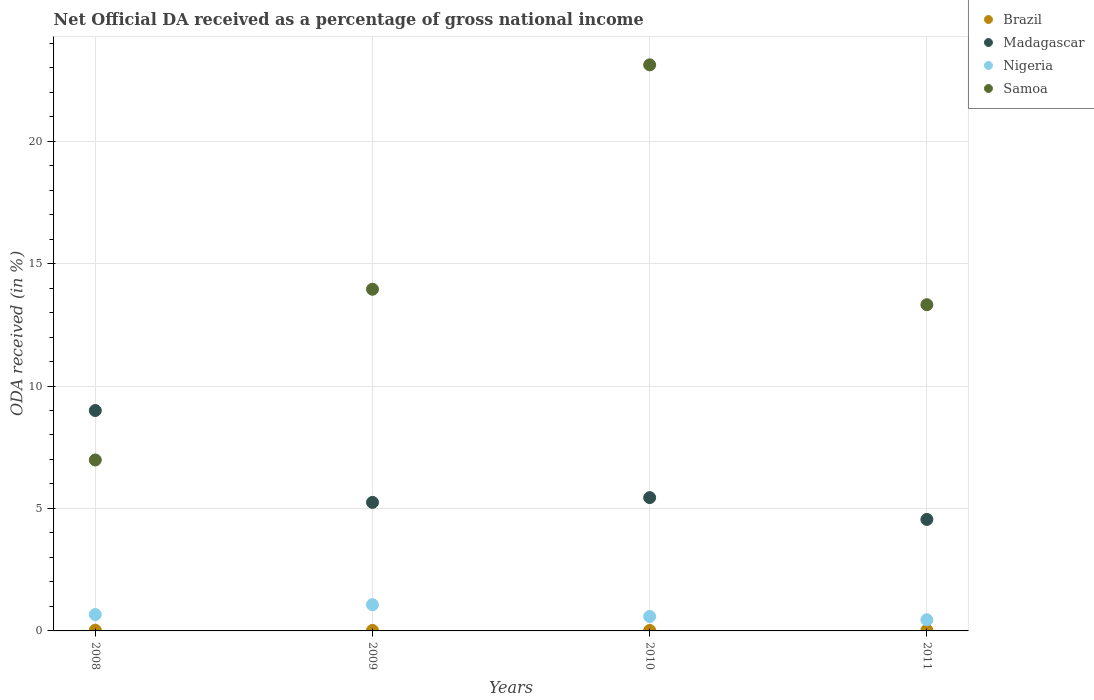How many different coloured dotlines are there?
Ensure brevity in your answer.  4. What is the net official DA received in Brazil in 2011?
Offer a very short reply. 0.03. Across all years, what is the maximum net official DA received in Samoa?
Your answer should be very brief. 23.11. Across all years, what is the minimum net official DA received in Brazil?
Provide a short and direct response. 0.02. In which year was the net official DA received in Nigeria minimum?
Ensure brevity in your answer.  2011. What is the total net official DA received in Nigeria in the graph?
Provide a succinct answer. 2.78. What is the difference between the net official DA received in Madagascar in 2009 and that in 2010?
Keep it short and to the point. -0.19. What is the difference between the net official DA received in Nigeria in 2010 and the net official DA received in Brazil in 2008?
Provide a short and direct response. 0.56. What is the average net official DA received in Nigeria per year?
Offer a very short reply. 0.7. In the year 2011, what is the difference between the net official DA received in Samoa and net official DA received in Nigeria?
Provide a short and direct response. 12.86. In how many years, is the net official DA received in Brazil greater than 8 %?
Offer a terse response. 0. What is the ratio of the net official DA received in Brazil in 2010 to that in 2011?
Provide a succinct answer. 0.66. Is the difference between the net official DA received in Samoa in 2008 and 2010 greater than the difference between the net official DA received in Nigeria in 2008 and 2010?
Keep it short and to the point. No. What is the difference between the highest and the second highest net official DA received in Madagascar?
Provide a short and direct response. 3.56. What is the difference between the highest and the lowest net official DA received in Samoa?
Provide a short and direct response. 16.13. Is it the case that in every year, the sum of the net official DA received in Nigeria and net official DA received in Madagascar  is greater than the sum of net official DA received in Brazil and net official DA received in Samoa?
Offer a terse response. Yes. Is the net official DA received in Samoa strictly greater than the net official DA received in Brazil over the years?
Provide a short and direct response. Yes. Is the net official DA received in Madagascar strictly less than the net official DA received in Brazil over the years?
Offer a terse response. No. How many dotlines are there?
Your response must be concise. 4. What is the difference between two consecutive major ticks on the Y-axis?
Keep it short and to the point. 5. Are the values on the major ticks of Y-axis written in scientific E-notation?
Make the answer very short. No. Where does the legend appear in the graph?
Give a very brief answer. Top right. How many legend labels are there?
Ensure brevity in your answer.  4. How are the legend labels stacked?
Give a very brief answer. Vertical. What is the title of the graph?
Provide a succinct answer. Net Official DA received as a percentage of gross national income. Does "Uruguay" appear as one of the legend labels in the graph?
Offer a terse response. No. What is the label or title of the Y-axis?
Offer a terse response. ODA received (in %). What is the ODA received (in %) in Brazil in 2008?
Give a very brief answer. 0.03. What is the ODA received (in %) in Madagascar in 2008?
Offer a very short reply. 9. What is the ODA received (in %) in Nigeria in 2008?
Keep it short and to the point. 0.67. What is the ODA received (in %) in Samoa in 2008?
Your response must be concise. 6.98. What is the ODA received (in %) in Brazil in 2009?
Keep it short and to the point. 0.02. What is the ODA received (in %) in Madagascar in 2009?
Provide a short and direct response. 5.25. What is the ODA received (in %) in Nigeria in 2009?
Provide a succinct answer. 1.07. What is the ODA received (in %) in Samoa in 2009?
Make the answer very short. 13.95. What is the ODA received (in %) in Brazil in 2010?
Your answer should be very brief. 0.02. What is the ODA received (in %) of Madagascar in 2010?
Provide a short and direct response. 5.44. What is the ODA received (in %) in Nigeria in 2010?
Keep it short and to the point. 0.59. What is the ODA received (in %) of Samoa in 2010?
Ensure brevity in your answer.  23.11. What is the ODA received (in %) in Brazil in 2011?
Your response must be concise. 0.03. What is the ODA received (in %) of Madagascar in 2011?
Offer a terse response. 4.55. What is the ODA received (in %) of Nigeria in 2011?
Give a very brief answer. 0.45. What is the ODA received (in %) in Samoa in 2011?
Provide a short and direct response. 13.32. Across all years, what is the maximum ODA received (in %) in Brazil?
Give a very brief answer. 0.03. Across all years, what is the maximum ODA received (in %) in Madagascar?
Give a very brief answer. 9. Across all years, what is the maximum ODA received (in %) in Nigeria?
Provide a short and direct response. 1.07. Across all years, what is the maximum ODA received (in %) in Samoa?
Offer a very short reply. 23.11. Across all years, what is the minimum ODA received (in %) in Brazil?
Offer a terse response. 0.02. Across all years, what is the minimum ODA received (in %) in Madagascar?
Your answer should be very brief. 4.55. Across all years, what is the minimum ODA received (in %) in Nigeria?
Keep it short and to the point. 0.45. Across all years, what is the minimum ODA received (in %) in Samoa?
Keep it short and to the point. 6.98. What is the total ODA received (in %) of Brazil in the graph?
Provide a short and direct response. 0.1. What is the total ODA received (in %) in Madagascar in the graph?
Provide a succinct answer. 24.24. What is the total ODA received (in %) of Nigeria in the graph?
Your answer should be compact. 2.78. What is the total ODA received (in %) in Samoa in the graph?
Make the answer very short. 57.36. What is the difference between the ODA received (in %) in Brazil in 2008 and that in 2009?
Offer a very short reply. 0.01. What is the difference between the ODA received (in %) in Madagascar in 2008 and that in 2009?
Keep it short and to the point. 3.75. What is the difference between the ODA received (in %) in Nigeria in 2008 and that in 2009?
Your answer should be very brief. -0.4. What is the difference between the ODA received (in %) in Samoa in 2008 and that in 2009?
Give a very brief answer. -6.97. What is the difference between the ODA received (in %) in Brazil in 2008 and that in 2010?
Give a very brief answer. 0.01. What is the difference between the ODA received (in %) in Madagascar in 2008 and that in 2010?
Make the answer very short. 3.56. What is the difference between the ODA received (in %) in Nigeria in 2008 and that in 2010?
Provide a succinct answer. 0.08. What is the difference between the ODA received (in %) of Samoa in 2008 and that in 2010?
Offer a very short reply. -16.13. What is the difference between the ODA received (in %) in Brazil in 2008 and that in 2011?
Your answer should be very brief. -0. What is the difference between the ODA received (in %) of Madagascar in 2008 and that in 2011?
Your answer should be very brief. 4.45. What is the difference between the ODA received (in %) in Nigeria in 2008 and that in 2011?
Keep it short and to the point. 0.21. What is the difference between the ODA received (in %) of Samoa in 2008 and that in 2011?
Give a very brief answer. -6.34. What is the difference between the ODA received (in %) of Madagascar in 2009 and that in 2010?
Ensure brevity in your answer.  -0.19. What is the difference between the ODA received (in %) of Nigeria in 2009 and that in 2010?
Your answer should be compact. 0.48. What is the difference between the ODA received (in %) of Samoa in 2009 and that in 2010?
Provide a succinct answer. -9.16. What is the difference between the ODA received (in %) in Brazil in 2009 and that in 2011?
Ensure brevity in your answer.  -0.01. What is the difference between the ODA received (in %) in Madagascar in 2009 and that in 2011?
Make the answer very short. 0.7. What is the difference between the ODA received (in %) in Nigeria in 2009 and that in 2011?
Your response must be concise. 0.61. What is the difference between the ODA received (in %) of Samoa in 2009 and that in 2011?
Ensure brevity in your answer.  0.63. What is the difference between the ODA received (in %) in Brazil in 2010 and that in 2011?
Your answer should be compact. -0.01. What is the difference between the ODA received (in %) of Madagascar in 2010 and that in 2011?
Make the answer very short. 0.89. What is the difference between the ODA received (in %) in Nigeria in 2010 and that in 2011?
Ensure brevity in your answer.  0.14. What is the difference between the ODA received (in %) in Samoa in 2010 and that in 2011?
Provide a succinct answer. 9.79. What is the difference between the ODA received (in %) of Brazil in 2008 and the ODA received (in %) of Madagascar in 2009?
Offer a very short reply. -5.22. What is the difference between the ODA received (in %) in Brazil in 2008 and the ODA received (in %) in Nigeria in 2009?
Offer a very short reply. -1.04. What is the difference between the ODA received (in %) of Brazil in 2008 and the ODA received (in %) of Samoa in 2009?
Ensure brevity in your answer.  -13.92. What is the difference between the ODA received (in %) of Madagascar in 2008 and the ODA received (in %) of Nigeria in 2009?
Ensure brevity in your answer.  7.93. What is the difference between the ODA received (in %) of Madagascar in 2008 and the ODA received (in %) of Samoa in 2009?
Your answer should be very brief. -4.95. What is the difference between the ODA received (in %) in Nigeria in 2008 and the ODA received (in %) in Samoa in 2009?
Ensure brevity in your answer.  -13.28. What is the difference between the ODA received (in %) of Brazil in 2008 and the ODA received (in %) of Madagascar in 2010?
Offer a very short reply. -5.41. What is the difference between the ODA received (in %) in Brazil in 2008 and the ODA received (in %) in Nigeria in 2010?
Your answer should be compact. -0.56. What is the difference between the ODA received (in %) of Brazil in 2008 and the ODA received (in %) of Samoa in 2010?
Provide a succinct answer. -23.08. What is the difference between the ODA received (in %) of Madagascar in 2008 and the ODA received (in %) of Nigeria in 2010?
Make the answer very short. 8.41. What is the difference between the ODA received (in %) in Madagascar in 2008 and the ODA received (in %) in Samoa in 2010?
Your answer should be very brief. -14.11. What is the difference between the ODA received (in %) of Nigeria in 2008 and the ODA received (in %) of Samoa in 2010?
Your answer should be compact. -22.44. What is the difference between the ODA received (in %) of Brazil in 2008 and the ODA received (in %) of Madagascar in 2011?
Your response must be concise. -4.52. What is the difference between the ODA received (in %) in Brazil in 2008 and the ODA received (in %) in Nigeria in 2011?
Your answer should be compact. -0.43. What is the difference between the ODA received (in %) of Brazil in 2008 and the ODA received (in %) of Samoa in 2011?
Your answer should be very brief. -13.29. What is the difference between the ODA received (in %) in Madagascar in 2008 and the ODA received (in %) in Nigeria in 2011?
Offer a very short reply. 8.54. What is the difference between the ODA received (in %) of Madagascar in 2008 and the ODA received (in %) of Samoa in 2011?
Ensure brevity in your answer.  -4.32. What is the difference between the ODA received (in %) of Nigeria in 2008 and the ODA received (in %) of Samoa in 2011?
Give a very brief answer. -12.65. What is the difference between the ODA received (in %) of Brazil in 2009 and the ODA received (in %) of Madagascar in 2010?
Ensure brevity in your answer.  -5.42. What is the difference between the ODA received (in %) of Brazil in 2009 and the ODA received (in %) of Nigeria in 2010?
Make the answer very short. -0.57. What is the difference between the ODA received (in %) in Brazil in 2009 and the ODA received (in %) in Samoa in 2010?
Make the answer very short. -23.09. What is the difference between the ODA received (in %) in Madagascar in 2009 and the ODA received (in %) in Nigeria in 2010?
Give a very brief answer. 4.66. What is the difference between the ODA received (in %) of Madagascar in 2009 and the ODA received (in %) of Samoa in 2010?
Keep it short and to the point. -17.86. What is the difference between the ODA received (in %) of Nigeria in 2009 and the ODA received (in %) of Samoa in 2010?
Your answer should be very brief. -22.04. What is the difference between the ODA received (in %) in Brazil in 2009 and the ODA received (in %) in Madagascar in 2011?
Your response must be concise. -4.53. What is the difference between the ODA received (in %) of Brazil in 2009 and the ODA received (in %) of Nigeria in 2011?
Offer a very short reply. -0.43. What is the difference between the ODA received (in %) in Brazil in 2009 and the ODA received (in %) in Samoa in 2011?
Make the answer very short. -13.3. What is the difference between the ODA received (in %) in Madagascar in 2009 and the ODA received (in %) in Nigeria in 2011?
Give a very brief answer. 4.79. What is the difference between the ODA received (in %) in Madagascar in 2009 and the ODA received (in %) in Samoa in 2011?
Provide a succinct answer. -8.07. What is the difference between the ODA received (in %) in Nigeria in 2009 and the ODA received (in %) in Samoa in 2011?
Keep it short and to the point. -12.25. What is the difference between the ODA received (in %) in Brazil in 2010 and the ODA received (in %) in Madagascar in 2011?
Offer a terse response. -4.53. What is the difference between the ODA received (in %) of Brazil in 2010 and the ODA received (in %) of Nigeria in 2011?
Make the answer very short. -0.43. What is the difference between the ODA received (in %) in Brazil in 2010 and the ODA received (in %) in Samoa in 2011?
Give a very brief answer. -13.3. What is the difference between the ODA received (in %) of Madagascar in 2010 and the ODA received (in %) of Nigeria in 2011?
Your answer should be compact. 4.99. What is the difference between the ODA received (in %) of Madagascar in 2010 and the ODA received (in %) of Samoa in 2011?
Your answer should be compact. -7.88. What is the difference between the ODA received (in %) in Nigeria in 2010 and the ODA received (in %) in Samoa in 2011?
Offer a very short reply. -12.73. What is the average ODA received (in %) of Brazil per year?
Keep it short and to the point. 0.03. What is the average ODA received (in %) of Madagascar per year?
Offer a very short reply. 6.06. What is the average ODA received (in %) in Nigeria per year?
Make the answer very short. 0.7. What is the average ODA received (in %) in Samoa per year?
Give a very brief answer. 14.34. In the year 2008, what is the difference between the ODA received (in %) in Brazil and ODA received (in %) in Madagascar?
Keep it short and to the point. -8.97. In the year 2008, what is the difference between the ODA received (in %) in Brazil and ODA received (in %) in Nigeria?
Keep it short and to the point. -0.64. In the year 2008, what is the difference between the ODA received (in %) in Brazil and ODA received (in %) in Samoa?
Provide a short and direct response. -6.95. In the year 2008, what is the difference between the ODA received (in %) in Madagascar and ODA received (in %) in Nigeria?
Give a very brief answer. 8.33. In the year 2008, what is the difference between the ODA received (in %) in Madagascar and ODA received (in %) in Samoa?
Make the answer very short. 2.02. In the year 2008, what is the difference between the ODA received (in %) in Nigeria and ODA received (in %) in Samoa?
Ensure brevity in your answer.  -6.31. In the year 2009, what is the difference between the ODA received (in %) in Brazil and ODA received (in %) in Madagascar?
Provide a succinct answer. -5.23. In the year 2009, what is the difference between the ODA received (in %) in Brazil and ODA received (in %) in Nigeria?
Ensure brevity in your answer.  -1.05. In the year 2009, what is the difference between the ODA received (in %) of Brazil and ODA received (in %) of Samoa?
Ensure brevity in your answer.  -13.93. In the year 2009, what is the difference between the ODA received (in %) of Madagascar and ODA received (in %) of Nigeria?
Ensure brevity in your answer.  4.18. In the year 2009, what is the difference between the ODA received (in %) of Madagascar and ODA received (in %) of Samoa?
Your answer should be compact. -8.7. In the year 2009, what is the difference between the ODA received (in %) in Nigeria and ODA received (in %) in Samoa?
Provide a short and direct response. -12.88. In the year 2010, what is the difference between the ODA received (in %) of Brazil and ODA received (in %) of Madagascar?
Your response must be concise. -5.42. In the year 2010, what is the difference between the ODA received (in %) of Brazil and ODA received (in %) of Nigeria?
Keep it short and to the point. -0.57. In the year 2010, what is the difference between the ODA received (in %) in Brazil and ODA received (in %) in Samoa?
Offer a terse response. -23.09. In the year 2010, what is the difference between the ODA received (in %) of Madagascar and ODA received (in %) of Nigeria?
Your answer should be compact. 4.85. In the year 2010, what is the difference between the ODA received (in %) in Madagascar and ODA received (in %) in Samoa?
Offer a very short reply. -17.67. In the year 2010, what is the difference between the ODA received (in %) of Nigeria and ODA received (in %) of Samoa?
Your answer should be compact. -22.52. In the year 2011, what is the difference between the ODA received (in %) of Brazil and ODA received (in %) of Madagascar?
Offer a terse response. -4.52. In the year 2011, what is the difference between the ODA received (in %) in Brazil and ODA received (in %) in Nigeria?
Offer a terse response. -0.42. In the year 2011, what is the difference between the ODA received (in %) of Brazil and ODA received (in %) of Samoa?
Offer a very short reply. -13.29. In the year 2011, what is the difference between the ODA received (in %) of Madagascar and ODA received (in %) of Nigeria?
Offer a very short reply. 4.1. In the year 2011, what is the difference between the ODA received (in %) of Madagascar and ODA received (in %) of Samoa?
Ensure brevity in your answer.  -8.77. In the year 2011, what is the difference between the ODA received (in %) in Nigeria and ODA received (in %) in Samoa?
Provide a short and direct response. -12.86. What is the ratio of the ODA received (in %) in Brazil in 2008 to that in 2009?
Give a very brief answer. 1.34. What is the ratio of the ODA received (in %) of Madagascar in 2008 to that in 2009?
Your answer should be very brief. 1.71. What is the ratio of the ODA received (in %) of Nigeria in 2008 to that in 2009?
Offer a terse response. 0.63. What is the ratio of the ODA received (in %) of Samoa in 2008 to that in 2009?
Offer a very short reply. 0.5. What is the ratio of the ODA received (in %) in Brazil in 2008 to that in 2010?
Keep it short and to the point. 1.37. What is the ratio of the ODA received (in %) in Madagascar in 2008 to that in 2010?
Your answer should be compact. 1.65. What is the ratio of the ODA received (in %) in Nigeria in 2008 to that in 2010?
Ensure brevity in your answer.  1.13. What is the ratio of the ODA received (in %) in Samoa in 2008 to that in 2010?
Your answer should be compact. 0.3. What is the ratio of the ODA received (in %) in Brazil in 2008 to that in 2011?
Your answer should be very brief. 0.9. What is the ratio of the ODA received (in %) of Madagascar in 2008 to that in 2011?
Provide a short and direct response. 1.98. What is the ratio of the ODA received (in %) of Nigeria in 2008 to that in 2011?
Your answer should be very brief. 1.47. What is the ratio of the ODA received (in %) of Samoa in 2008 to that in 2011?
Give a very brief answer. 0.52. What is the ratio of the ODA received (in %) in Brazil in 2009 to that in 2010?
Offer a very short reply. 1.02. What is the ratio of the ODA received (in %) in Nigeria in 2009 to that in 2010?
Your answer should be very brief. 1.81. What is the ratio of the ODA received (in %) of Samoa in 2009 to that in 2010?
Provide a succinct answer. 0.6. What is the ratio of the ODA received (in %) in Brazil in 2009 to that in 2011?
Give a very brief answer. 0.67. What is the ratio of the ODA received (in %) in Madagascar in 2009 to that in 2011?
Give a very brief answer. 1.15. What is the ratio of the ODA received (in %) of Nigeria in 2009 to that in 2011?
Offer a terse response. 2.35. What is the ratio of the ODA received (in %) of Samoa in 2009 to that in 2011?
Keep it short and to the point. 1.05. What is the ratio of the ODA received (in %) of Brazil in 2010 to that in 2011?
Offer a terse response. 0.66. What is the ratio of the ODA received (in %) in Madagascar in 2010 to that in 2011?
Give a very brief answer. 1.2. What is the ratio of the ODA received (in %) of Nigeria in 2010 to that in 2011?
Your answer should be compact. 1.3. What is the ratio of the ODA received (in %) in Samoa in 2010 to that in 2011?
Your answer should be very brief. 1.74. What is the difference between the highest and the second highest ODA received (in %) of Brazil?
Make the answer very short. 0. What is the difference between the highest and the second highest ODA received (in %) of Madagascar?
Your answer should be compact. 3.56. What is the difference between the highest and the second highest ODA received (in %) in Nigeria?
Give a very brief answer. 0.4. What is the difference between the highest and the second highest ODA received (in %) of Samoa?
Provide a succinct answer. 9.16. What is the difference between the highest and the lowest ODA received (in %) in Brazil?
Provide a succinct answer. 0.01. What is the difference between the highest and the lowest ODA received (in %) of Madagascar?
Make the answer very short. 4.45. What is the difference between the highest and the lowest ODA received (in %) in Nigeria?
Keep it short and to the point. 0.61. What is the difference between the highest and the lowest ODA received (in %) of Samoa?
Give a very brief answer. 16.13. 